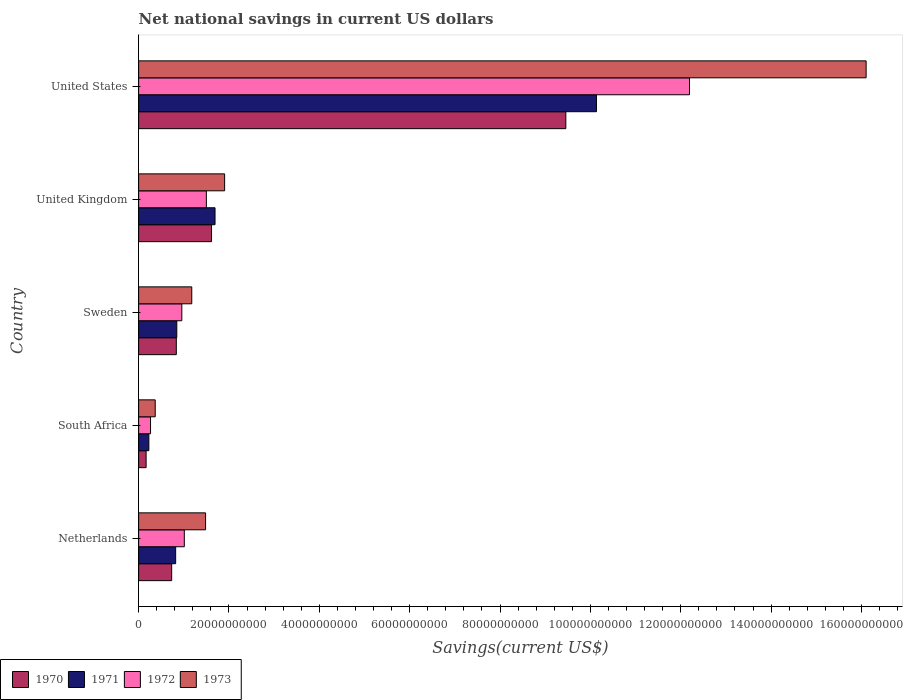Are the number of bars on each tick of the Y-axis equal?
Your answer should be compact. Yes. How many bars are there on the 5th tick from the top?
Keep it short and to the point. 4. What is the label of the 4th group of bars from the top?
Your answer should be very brief. South Africa. In how many cases, is the number of bars for a given country not equal to the number of legend labels?
Make the answer very short. 0. What is the net national savings in 1970 in United Kingdom?
Offer a very short reply. 1.61e+1. Across all countries, what is the maximum net national savings in 1971?
Your answer should be compact. 1.01e+11. Across all countries, what is the minimum net national savings in 1973?
Your response must be concise. 3.67e+09. In which country was the net national savings in 1973 maximum?
Offer a very short reply. United States. In which country was the net national savings in 1973 minimum?
Offer a terse response. South Africa. What is the total net national savings in 1973 in the graph?
Provide a succinct answer. 2.10e+11. What is the difference between the net national savings in 1971 in South Africa and that in Sweden?
Your answer should be compact. -6.18e+09. What is the difference between the net national savings in 1972 in United States and the net national savings in 1971 in Netherlands?
Offer a very short reply. 1.14e+11. What is the average net national savings in 1972 per country?
Your response must be concise. 3.18e+1. What is the difference between the net national savings in 1971 and net national savings in 1973 in United States?
Your response must be concise. -5.97e+1. In how many countries, is the net national savings in 1973 greater than 84000000000 US$?
Make the answer very short. 1. What is the ratio of the net national savings in 1971 in South Africa to that in United States?
Give a very brief answer. 0.02. Is the difference between the net national savings in 1971 in Sweden and United Kingdom greater than the difference between the net national savings in 1973 in Sweden and United Kingdom?
Your response must be concise. No. What is the difference between the highest and the second highest net national savings in 1970?
Make the answer very short. 7.84e+1. What is the difference between the highest and the lowest net national savings in 1973?
Keep it short and to the point. 1.57e+11. Is it the case that in every country, the sum of the net national savings in 1973 and net national savings in 1971 is greater than the sum of net national savings in 1972 and net national savings in 1970?
Offer a terse response. No. What does the 1st bar from the bottom in Sweden represents?
Provide a short and direct response. 1970. Is it the case that in every country, the sum of the net national savings in 1973 and net national savings in 1972 is greater than the net national savings in 1971?
Offer a terse response. Yes. How many bars are there?
Make the answer very short. 20. How many countries are there in the graph?
Offer a very short reply. 5. Are the values on the major ticks of X-axis written in scientific E-notation?
Ensure brevity in your answer.  No. How many legend labels are there?
Your response must be concise. 4. How are the legend labels stacked?
Give a very brief answer. Horizontal. What is the title of the graph?
Offer a very short reply. Net national savings in current US dollars. Does "1995" appear as one of the legend labels in the graph?
Offer a terse response. No. What is the label or title of the X-axis?
Offer a terse response. Savings(current US$). What is the Savings(current US$) in 1970 in Netherlands?
Offer a terse response. 7.31e+09. What is the Savings(current US$) in 1971 in Netherlands?
Offer a very short reply. 8.20e+09. What is the Savings(current US$) of 1972 in Netherlands?
Give a very brief answer. 1.01e+1. What is the Savings(current US$) in 1973 in Netherlands?
Your answer should be compact. 1.48e+1. What is the Savings(current US$) in 1970 in South Africa?
Ensure brevity in your answer.  1.66e+09. What is the Savings(current US$) of 1971 in South Africa?
Offer a very short reply. 2.27e+09. What is the Savings(current US$) of 1972 in South Africa?
Provide a succinct answer. 2.64e+09. What is the Savings(current US$) in 1973 in South Africa?
Your response must be concise. 3.67e+09. What is the Savings(current US$) of 1970 in Sweden?
Provide a succinct answer. 8.34e+09. What is the Savings(current US$) of 1971 in Sweden?
Provide a succinct answer. 8.45e+09. What is the Savings(current US$) in 1972 in Sweden?
Provide a succinct answer. 9.56e+09. What is the Savings(current US$) of 1973 in Sweden?
Your response must be concise. 1.18e+1. What is the Savings(current US$) of 1970 in United Kingdom?
Your answer should be compact. 1.61e+1. What is the Savings(current US$) of 1971 in United Kingdom?
Provide a short and direct response. 1.69e+1. What is the Savings(current US$) in 1972 in United Kingdom?
Give a very brief answer. 1.50e+1. What is the Savings(current US$) in 1973 in United Kingdom?
Provide a short and direct response. 1.90e+1. What is the Savings(current US$) of 1970 in United States?
Your response must be concise. 9.46e+1. What is the Savings(current US$) in 1971 in United States?
Make the answer very short. 1.01e+11. What is the Savings(current US$) in 1972 in United States?
Provide a succinct answer. 1.22e+11. What is the Savings(current US$) in 1973 in United States?
Provide a succinct answer. 1.61e+11. Across all countries, what is the maximum Savings(current US$) in 1970?
Your response must be concise. 9.46e+1. Across all countries, what is the maximum Savings(current US$) of 1971?
Make the answer very short. 1.01e+11. Across all countries, what is the maximum Savings(current US$) of 1972?
Provide a succinct answer. 1.22e+11. Across all countries, what is the maximum Savings(current US$) in 1973?
Offer a terse response. 1.61e+11. Across all countries, what is the minimum Savings(current US$) in 1970?
Keep it short and to the point. 1.66e+09. Across all countries, what is the minimum Savings(current US$) in 1971?
Give a very brief answer. 2.27e+09. Across all countries, what is the minimum Savings(current US$) of 1972?
Your response must be concise. 2.64e+09. Across all countries, what is the minimum Savings(current US$) in 1973?
Offer a terse response. 3.67e+09. What is the total Savings(current US$) in 1970 in the graph?
Make the answer very short. 1.28e+11. What is the total Savings(current US$) of 1971 in the graph?
Your answer should be compact. 1.37e+11. What is the total Savings(current US$) in 1972 in the graph?
Ensure brevity in your answer.  1.59e+11. What is the total Savings(current US$) of 1973 in the graph?
Make the answer very short. 2.10e+11. What is the difference between the Savings(current US$) in 1970 in Netherlands and that in South Africa?
Provide a short and direct response. 5.66e+09. What is the difference between the Savings(current US$) in 1971 in Netherlands and that in South Africa?
Offer a very short reply. 5.93e+09. What is the difference between the Savings(current US$) in 1972 in Netherlands and that in South Africa?
Make the answer very short. 7.48e+09. What is the difference between the Savings(current US$) in 1973 in Netherlands and that in South Africa?
Your response must be concise. 1.11e+1. What is the difference between the Savings(current US$) in 1970 in Netherlands and that in Sweden?
Make the answer very short. -1.03e+09. What is the difference between the Savings(current US$) of 1971 in Netherlands and that in Sweden?
Your answer should be very brief. -2.53e+08. What is the difference between the Savings(current US$) of 1972 in Netherlands and that in Sweden?
Your answer should be very brief. 5.54e+08. What is the difference between the Savings(current US$) in 1973 in Netherlands and that in Sweden?
Your response must be concise. 3.06e+09. What is the difference between the Savings(current US$) of 1970 in Netherlands and that in United Kingdom?
Ensure brevity in your answer.  -8.83e+09. What is the difference between the Savings(current US$) in 1971 in Netherlands and that in United Kingdom?
Offer a terse response. -8.72e+09. What is the difference between the Savings(current US$) of 1972 in Netherlands and that in United Kingdom?
Make the answer very short. -4.88e+09. What is the difference between the Savings(current US$) of 1973 in Netherlands and that in United Kingdom?
Provide a short and direct response. -4.22e+09. What is the difference between the Savings(current US$) of 1970 in Netherlands and that in United States?
Provide a short and direct response. -8.72e+1. What is the difference between the Savings(current US$) in 1971 in Netherlands and that in United States?
Your answer should be compact. -9.31e+1. What is the difference between the Savings(current US$) of 1972 in Netherlands and that in United States?
Your answer should be very brief. -1.12e+11. What is the difference between the Savings(current US$) in 1973 in Netherlands and that in United States?
Keep it short and to the point. -1.46e+11. What is the difference between the Savings(current US$) in 1970 in South Africa and that in Sweden?
Offer a terse response. -6.69e+09. What is the difference between the Savings(current US$) of 1971 in South Africa and that in Sweden?
Make the answer very short. -6.18e+09. What is the difference between the Savings(current US$) of 1972 in South Africa and that in Sweden?
Keep it short and to the point. -6.92e+09. What is the difference between the Savings(current US$) in 1973 in South Africa and that in Sweden?
Your response must be concise. -8.09e+09. What is the difference between the Savings(current US$) of 1970 in South Africa and that in United Kingdom?
Provide a short and direct response. -1.45e+1. What is the difference between the Savings(current US$) of 1971 in South Africa and that in United Kingdom?
Your response must be concise. -1.46e+1. What is the difference between the Savings(current US$) in 1972 in South Africa and that in United Kingdom?
Give a very brief answer. -1.24e+1. What is the difference between the Savings(current US$) in 1973 in South Africa and that in United Kingdom?
Your answer should be very brief. -1.54e+1. What is the difference between the Savings(current US$) of 1970 in South Africa and that in United States?
Provide a short and direct response. -9.29e+1. What is the difference between the Savings(current US$) of 1971 in South Africa and that in United States?
Offer a terse response. -9.91e+1. What is the difference between the Savings(current US$) of 1972 in South Africa and that in United States?
Provide a short and direct response. -1.19e+11. What is the difference between the Savings(current US$) of 1973 in South Africa and that in United States?
Offer a terse response. -1.57e+11. What is the difference between the Savings(current US$) of 1970 in Sweden and that in United Kingdom?
Your answer should be very brief. -7.80e+09. What is the difference between the Savings(current US$) of 1971 in Sweden and that in United Kingdom?
Keep it short and to the point. -8.46e+09. What is the difference between the Savings(current US$) of 1972 in Sweden and that in United Kingdom?
Offer a terse response. -5.43e+09. What is the difference between the Savings(current US$) in 1973 in Sweden and that in United Kingdom?
Offer a terse response. -7.27e+09. What is the difference between the Savings(current US$) in 1970 in Sweden and that in United States?
Give a very brief answer. -8.62e+1. What is the difference between the Savings(current US$) of 1971 in Sweden and that in United States?
Provide a succinct answer. -9.29e+1. What is the difference between the Savings(current US$) in 1972 in Sweden and that in United States?
Keep it short and to the point. -1.12e+11. What is the difference between the Savings(current US$) in 1973 in Sweden and that in United States?
Your answer should be compact. -1.49e+11. What is the difference between the Savings(current US$) of 1970 in United Kingdom and that in United States?
Offer a very short reply. -7.84e+1. What is the difference between the Savings(current US$) in 1971 in United Kingdom and that in United States?
Offer a very short reply. -8.44e+1. What is the difference between the Savings(current US$) of 1972 in United Kingdom and that in United States?
Your response must be concise. -1.07e+11. What is the difference between the Savings(current US$) in 1973 in United Kingdom and that in United States?
Keep it short and to the point. -1.42e+11. What is the difference between the Savings(current US$) of 1970 in Netherlands and the Savings(current US$) of 1971 in South Africa?
Your response must be concise. 5.05e+09. What is the difference between the Savings(current US$) in 1970 in Netherlands and the Savings(current US$) in 1972 in South Africa?
Give a very brief answer. 4.68e+09. What is the difference between the Savings(current US$) of 1970 in Netherlands and the Savings(current US$) of 1973 in South Africa?
Your answer should be very brief. 3.64e+09. What is the difference between the Savings(current US$) of 1971 in Netherlands and the Savings(current US$) of 1972 in South Africa?
Provide a succinct answer. 5.56e+09. What is the difference between the Savings(current US$) of 1971 in Netherlands and the Savings(current US$) of 1973 in South Africa?
Your response must be concise. 4.52e+09. What is the difference between the Savings(current US$) of 1972 in Netherlands and the Savings(current US$) of 1973 in South Africa?
Keep it short and to the point. 6.44e+09. What is the difference between the Savings(current US$) of 1970 in Netherlands and the Savings(current US$) of 1971 in Sweden?
Provide a succinct answer. -1.14e+09. What is the difference between the Savings(current US$) in 1970 in Netherlands and the Savings(current US$) in 1972 in Sweden?
Provide a succinct answer. -2.25e+09. What is the difference between the Savings(current US$) in 1970 in Netherlands and the Savings(current US$) in 1973 in Sweden?
Give a very brief answer. -4.45e+09. What is the difference between the Savings(current US$) in 1971 in Netherlands and the Savings(current US$) in 1972 in Sweden?
Provide a succinct answer. -1.36e+09. What is the difference between the Savings(current US$) in 1971 in Netherlands and the Savings(current US$) in 1973 in Sweden?
Ensure brevity in your answer.  -3.57e+09. What is the difference between the Savings(current US$) of 1972 in Netherlands and the Savings(current US$) of 1973 in Sweden?
Offer a terse response. -1.65e+09. What is the difference between the Savings(current US$) of 1970 in Netherlands and the Savings(current US$) of 1971 in United Kingdom?
Provide a short and direct response. -9.60e+09. What is the difference between the Savings(current US$) of 1970 in Netherlands and the Savings(current US$) of 1972 in United Kingdom?
Your answer should be compact. -7.68e+09. What is the difference between the Savings(current US$) of 1970 in Netherlands and the Savings(current US$) of 1973 in United Kingdom?
Provide a succinct answer. -1.17e+1. What is the difference between the Savings(current US$) in 1971 in Netherlands and the Savings(current US$) in 1972 in United Kingdom?
Your response must be concise. -6.80e+09. What is the difference between the Savings(current US$) of 1971 in Netherlands and the Savings(current US$) of 1973 in United Kingdom?
Give a very brief answer. -1.08e+1. What is the difference between the Savings(current US$) of 1972 in Netherlands and the Savings(current US$) of 1973 in United Kingdom?
Offer a very short reply. -8.92e+09. What is the difference between the Savings(current US$) of 1970 in Netherlands and the Savings(current US$) of 1971 in United States?
Provide a succinct answer. -9.40e+1. What is the difference between the Savings(current US$) in 1970 in Netherlands and the Savings(current US$) in 1972 in United States?
Keep it short and to the point. -1.15e+11. What is the difference between the Savings(current US$) of 1970 in Netherlands and the Savings(current US$) of 1973 in United States?
Give a very brief answer. -1.54e+11. What is the difference between the Savings(current US$) of 1971 in Netherlands and the Savings(current US$) of 1972 in United States?
Your response must be concise. -1.14e+11. What is the difference between the Savings(current US$) in 1971 in Netherlands and the Savings(current US$) in 1973 in United States?
Your answer should be compact. -1.53e+11. What is the difference between the Savings(current US$) in 1972 in Netherlands and the Savings(current US$) in 1973 in United States?
Your answer should be very brief. -1.51e+11. What is the difference between the Savings(current US$) of 1970 in South Africa and the Savings(current US$) of 1971 in Sweden?
Make the answer very short. -6.79e+09. What is the difference between the Savings(current US$) of 1970 in South Africa and the Savings(current US$) of 1972 in Sweden?
Keep it short and to the point. -7.90e+09. What is the difference between the Savings(current US$) in 1970 in South Africa and the Savings(current US$) in 1973 in Sweden?
Provide a succinct answer. -1.01e+1. What is the difference between the Savings(current US$) in 1971 in South Africa and the Savings(current US$) in 1972 in Sweden?
Your response must be concise. -7.29e+09. What is the difference between the Savings(current US$) in 1971 in South Africa and the Savings(current US$) in 1973 in Sweden?
Keep it short and to the point. -9.50e+09. What is the difference between the Savings(current US$) of 1972 in South Africa and the Savings(current US$) of 1973 in Sweden?
Give a very brief answer. -9.13e+09. What is the difference between the Savings(current US$) in 1970 in South Africa and the Savings(current US$) in 1971 in United Kingdom?
Provide a succinct answer. -1.53e+1. What is the difference between the Savings(current US$) in 1970 in South Africa and the Savings(current US$) in 1972 in United Kingdom?
Your response must be concise. -1.33e+1. What is the difference between the Savings(current US$) in 1970 in South Africa and the Savings(current US$) in 1973 in United Kingdom?
Offer a very short reply. -1.74e+1. What is the difference between the Savings(current US$) in 1971 in South Africa and the Savings(current US$) in 1972 in United Kingdom?
Keep it short and to the point. -1.27e+1. What is the difference between the Savings(current US$) in 1971 in South Africa and the Savings(current US$) in 1973 in United Kingdom?
Make the answer very short. -1.68e+1. What is the difference between the Savings(current US$) in 1972 in South Africa and the Savings(current US$) in 1973 in United Kingdom?
Give a very brief answer. -1.64e+1. What is the difference between the Savings(current US$) of 1970 in South Africa and the Savings(current US$) of 1971 in United States?
Offer a very short reply. -9.97e+1. What is the difference between the Savings(current US$) of 1970 in South Africa and the Savings(current US$) of 1972 in United States?
Your answer should be very brief. -1.20e+11. What is the difference between the Savings(current US$) in 1970 in South Africa and the Savings(current US$) in 1973 in United States?
Keep it short and to the point. -1.59e+11. What is the difference between the Savings(current US$) in 1971 in South Africa and the Savings(current US$) in 1972 in United States?
Your answer should be very brief. -1.20e+11. What is the difference between the Savings(current US$) of 1971 in South Africa and the Savings(current US$) of 1973 in United States?
Give a very brief answer. -1.59e+11. What is the difference between the Savings(current US$) of 1972 in South Africa and the Savings(current US$) of 1973 in United States?
Your response must be concise. -1.58e+11. What is the difference between the Savings(current US$) of 1970 in Sweden and the Savings(current US$) of 1971 in United Kingdom?
Your answer should be very brief. -8.57e+09. What is the difference between the Savings(current US$) in 1970 in Sweden and the Savings(current US$) in 1972 in United Kingdom?
Your answer should be compact. -6.65e+09. What is the difference between the Savings(current US$) in 1970 in Sweden and the Savings(current US$) in 1973 in United Kingdom?
Keep it short and to the point. -1.07e+1. What is the difference between the Savings(current US$) in 1971 in Sweden and the Savings(current US$) in 1972 in United Kingdom?
Your answer should be compact. -6.54e+09. What is the difference between the Savings(current US$) of 1971 in Sweden and the Savings(current US$) of 1973 in United Kingdom?
Ensure brevity in your answer.  -1.06e+1. What is the difference between the Savings(current US$) in 1972 in Sweden and the Savings(current US$) in 1973 in United Kingdom?
Offer a very short reply. -9.48e+09. What is the difference between the Savings(current US$) of 1970 in Sweden and the Savings(current US$) of 1971 in United States?
Give a very brief answer. -9.30e+1. What is the difference between the Savings(current US$) of 1970 in Sweden and the Savings(current US$) of 1972 in United States?
Keep it short and to the point. -1.14e+11. What is the difference between the Savings(current US$) of 1970 in Sweden and the Savings(current US$) of 1973 in United States?
Keep it short and to the point. -1.53e+11. What is the difference between the Savings(current US$) in 1971 in Sweden and the Savings(current US$) in 1972 in United States?
Make the answer very short. -1.13e+11. What is the difference between the Savings(current US$) in 1971 in Sweden and the Savings(current US$) in 1973 in United States?
Ensure brevity in your answer.  -1.53e+11. What is the difference between the Savings(current US$) of 1972 in Sweden and the Savings(current US$) of 1973 in United States?
Make the answer very short. -1.51e+11. What is the difference between the Savings(current US$) of 1970 in United Kingdom and the Savings(current US$) of 1971 in United States?
Provide a succinct answer. -8.52e+1. What is the difference between the Savings(current US$) of 1970 in United Kingdom and the Savings(current US$) of 1972 in United States?
Offer a terse response. -1.06e+11. What is the difference between the Savings(current US$) of 1970 in United Kingdom and the Savings(current US$) of 1973 in United States?
Offer a very short reply. -1.45e+11. What is the difference between the Savings(current US$) of 1971 in United Kingdom and the Savings(current US$) of 1972 in United States?
Your answer should be compact. -1.05e+11. What is the difference between the Savings(current US$) in 1971 in United Kingdom and the Savings(current US$) in 1973 in United States?
Make the answer very short. -1.44e+11. What is the difference between the Savings(current US$) of 1972 in United Kingdom and the Savings(current US$) of 1973 in United States?
Provide a short and direct response. -1.46e+11. What is the average Savings(current US$) of 1970 per country?
Provide a short and direct response. 2.56e+1. What is the average Savings(current US$) of 1971 per country?
Offer a very short reply. 2.74e+1. What is the average Savings(current US$) in 1972 per country?
Offer a very short reply. 3.18e+1. What is the average Savings(current US$) of 1973 per country?
Give a very brief answer. 4.21e+1. What is the difference between the Savings(current US$) in 1970 and Savings(current US$) in 1971 in Netherlands?
Offer a terse response. -8.83e+08. What is the difference between the Savings(current US$) in 1970 and Savings(current US$) in 1972 in Netherlands?
Provide a short and direct response. -2.80e+09. What is the difference between the Savings(current US$) in 1970 and Savings(current US$) in 1973 in Netherlands?
Provide a succinct answer. -7.51e+09. What is the difference between the Savings(current US$) in 1971 and Savings(current US$) in 1972 in Netherlands?
Your response must be concise. -1.92e+09. What is the difference between the Savings(current US$) in 1971 and Savings(current US$) in 1973 in Netherlands?
Your response must be concise. -6.62e+09. What is the difference between the Savings(current US$) of 1972 and Savings(current US$) of 1973 in Netherlands?
Keep it short and to the point. -4.71e+09. What is the difference between the Savings(current US$) of 1970 and Savings(current US$) of 1971 in South Africa?
Make the answer very short. -6.09e+08. What is the difference between the Savings(current US$) of 1970 and Savings(current US$) of 1972 in South Africa?
Provide a short and direct response. -9.79e+08. What is the difference between the Savings(current US$) in 1970 and Savings(current US$) in 1973 in South Africa?
Provide a short and direct response. -2.02e+09. What is the difference between the Savings(current US$) of 1971 and Savings(current US$) of 1972 in South Africa?
Offer a terse response. -3.70e+08. What is the difference between the Savings(current US$) of 1971 and Savings(current US$) of 1973 in South Africa?
Your answer should be very brief. -1.41e+09. What is the difference between the Savings(current US$) of 1972 and Savings(current US$) of 1973 in South Africa?
Provide a succinct answer. -1.04e+09. What is the difference between the Savings(current US$) in 1970 and Savings(current US$) in 1971 in Sweden?
Offer a very short reply. -1.07e+08. What is the difference between the Savings(current US$) of 1970 and Savings(current US$) of 1972 in Sweden?
Your response must be concise. -1.22e+09. What is the difference between the Savings(current US$) of 1970 and Savings(current US$) of 1973 in Sweden?
Your answer should be very brief. -3.42e+09. What is the difference between the Savings(current US$) of 1971 and Savings(current US$) of 1972 in Sweden?
Make the answer very short. -1.11e+09. What is the difference between the Savings(current US$) of 1971 and Savings(current US$) of 1973 in Sweden?
Offer a very short reply. -3.31e+09. What is the difference between the Savings(current US$) of 1972 and Savings(current US$) of 1973 in Sweden?
Offer a very short reply. -2.20e+09. What is the difference between the Savings(current US$) of 1970 and Savings(current US$) of 1971 in United Kingdom?
Your answer should be compact. -7.74e+08. What is the difference between the Savings(current US$) of 1970 and Savings(current US$) of 1972 in United Kingdom?
Offer a terse response. 1.15e+09. What is the difference between the Savings(current US$) of 1970 and Savings(current US$) of 1973 in United Kingdom?
Give a very brief answer. -2.90e+09. What is the difference between the Savings(current US$) in 1971 and Savings(current US$) in 1972 in United Kingdom?
Make the answer very short. 1.92e+09. What is the difference between the Savings(current US$) in 1971 and Savings(current US$) in 1973 in United Kingdom?
Provide a short and direct response. -2.12e+09. What is the difference between the Savings(current US$) of 1972 and Savings(current US$) of 1973 in United Kingdom?
Offer a very short reply. -4.04e+09. What is the difference between the Savings(current US$) of 1970 and Savings(current US$) of 1971 in United States?
Offer a very short reply. -6.78e+09. What is the difference between the Savings(current US$) of 1970 and Savings(current US$) of 1972 in United States?
Your answer should be very brief. -2.74e+1. What is the difference between the Savings(current US$) of 1970 and Savings(current US$) of 1973 in United States?
Your answer should be compact. -6.65e+1. What is the difference between the Savings(current US$) in 1971 and Savings(current US$) in 1972 in United States?
Make the answer very short. -2.06e+1. What is the difference between the Savings(current US$) in 1971 and Savings(current US$) in 1973 in United States?
Offer a very short reply. -5.97e+1. What is the difference between the Savings(current US$) of 1972 and Savings(current US$) of 1973 in United States?
Ensure brevity in your answer.  -3.91e+1. What is the ratio of the Savings(current US$) in 1970 in Netherlands to that in South Africa?
Your answer should be very brief. 4.42. What is the ratio of the Savings(current US$) of 1971 in Netherlands to that in South Africa?
Provide a succinct answer. 3.62. What is the ratio of the Savings(current US$) of 1972 in Netherlands to that in South Africa?
Keep it short and to the point. 3.84. What is the ratio of the Savings(current US$) in 1973 in Netherlands to that in South Africa?
Make the answer very short. 4.04. What is the ratio of the Savings(current US$) in 1970 in Netherlands to that in Sweden?
Ensure brevity in your answer.  0.88. What is the ratio of the Savings(current US$) of 1972 in Netherlands to that in Sweden?
Offer a terse response. 1.06. What is the ratio of the Savings(current US$) in 1973 in Netherlands to that in Sweden?
Your answer should be very brief. 1.26. What is the ratio of the Savings(current US$) of 1970 in Netherlands to that in United Kingdom?
Give a very brief answer. 0.45. What is the ratio of the Savings(current US$) of 1971 in Netherlands to that in United Kingdom?
Keep it short and to the point. 0.48. What is the ratio of the Savings(current US$) in 1972 in Netherlands to that in United Kingdom?
Provide a short and direct response. 0.67. What is the ratio of the Savings(current US$) of 1973 in Netherlands to that in United Kingdom?
Offer a very short reply. 0.78. What is the ratio of the Savings(current US$) in 1970 in Netherlands to that in United States?
Offer a very short reply. 0.08. What is the ratio of the Savings(current US$) of 1971 in Netherlands to that in United States?
Provide a succinct answer. 0.08. What is the ratio of the Savings(current US$) in 1972 in Netherlands to that in United States?
Provide a short and direct response. 0.08. What is the ratio of the Savings(current US$) in 1973 in Netherlands to that in United States?
Provide a succinct answer. 0.09. What is the ratio of the Savings(current US$) in 1970 in South Africa to that in Sweden?
Make the answer very short. 0.2. What is the ratio of the Savings(current US$) of 1971 in South Africa to that in Sweden?
Give a very brief answer. 0.27. What is the ratio of the Savings(current US$) of 1972 in South Africa to that in Sweden?
Your answer should be compact. 0.28. What is the ratio of the Savings(current US$) in 1973 in South Africa to that in Sweden?
Ensure brevity in your answer.  0.31. What is the ratio of the Savings(current US$) of 1970 in South Africa to that in United Kingdom?
Make the answer very short. 0.1. What is the ratio of the Savings(current US$) of 1971 in South Africa to that in United Kingdom?
Offer a terse response. 0.13. What is the ratio of the Savings(current US$) in 1972 in South Africa to that in United Kingdom?
Ensure brevity in your answer.  0.18. What is the ratio of the Savings(current US$) in 1973 in South Africa to that in United Kingdom?
Give a very brief answer. 0.19. What is the ratio of the Savings(current US$) of 1970 in South Africa to that in United States?
Give a very brief answer. 0.02. What is the ratio of the Savings(current US$) of 1971 in South Africa to that in United States?
Your response must be concise. 0.02. What is the ratio of the Savings(current US$) in 1972 in South Africa to that in United States?
Your answer should be very brief. 0.02. What is the ratio of the Savings(current US$) of 1973 in South Africa to that in United States?
Ensure brevity in your answer.  0.02. What is the ratio of the Savings(current US$) in 1970 in Sweden to that in United Kingdom?
Offer a terse response. 0.52. What is the ratio of the Savings(current US$) of 1971 in Sweden to that in United Kingdom?
Keep it short and to the point. 0.5. What is the ratio of the Savings(current US$) of 1972 in Sweden to that in United Kingdom?
Keep it short and to the point. 0.64. What is the ratio of the Savings(current US$) in 1973 in Sweden to that in United Kingdom?
Make the answer very short. 0.62. What is the ratio of the Savings(current US$) in 1970 in Sweden to that in United States?
Your answer should be compact. 0.09. What is the ratio of the Savings(current US$) in 1971 in Sweden to that in United States?
Your answer should be compact. 0.08. What is the ratio of the Savings(current US$) of 1972 in Sweden to that in United States?
Make the answer very short. 0.08. What is the ratio of the Savings(current US$) in 1973 in Sweden to that in United States?
Make the answer very short. 0.07. What is the ratio of the Savings(current US$) in 1970 in United Kingdom to that in United States?
Your answer should be very brief. 0.17. What is the ratio of the Savings(current US$) of 1971 in United Kingdom to that in United States?
Offer a terse response. 0.17. What is the ratio of the Savings(current US$) in 1972 in United Kingdom to that in United States?
Offer a terse response. 0.12. What is the ratio of the Savings(current US$) of 1973 in United Kingdom to that in United States?
Make the answer very short. 0.12. What is the difference between the highest and the second highest Savings(current US$) of 1970?
Provide a short and direct response. 7.84e+1. What is the difference between the highest and the second highest Savings(current US$) in 1971?
Give a very brief answer. 8.44e+1. What is the difference between the highest and the second highest Savings(current US$) of 1972?
Offer a terse response. 1.07e+11. What is the difference between the highest and the second highest Savings(current US$) in 1973?
Give a very brief answer. 1.42e+11. What is the difference between the highest and the lowest Savings(current US$) in 1970?
Provide a short and direct response. 9.29e+1. What is the difference between the highest and the lowest Savings(current US$) in 1971?
Ensure brevity in your answer.  9.91e+1. What is the difference between the highest and the lowest Savings(current US$) of 1972?
Offer a very short reply. 1.19e+11. What is the difference between the highest and the lowest Savings(current US$) of 1973?
Offer a terse response. 1.57e+11. 